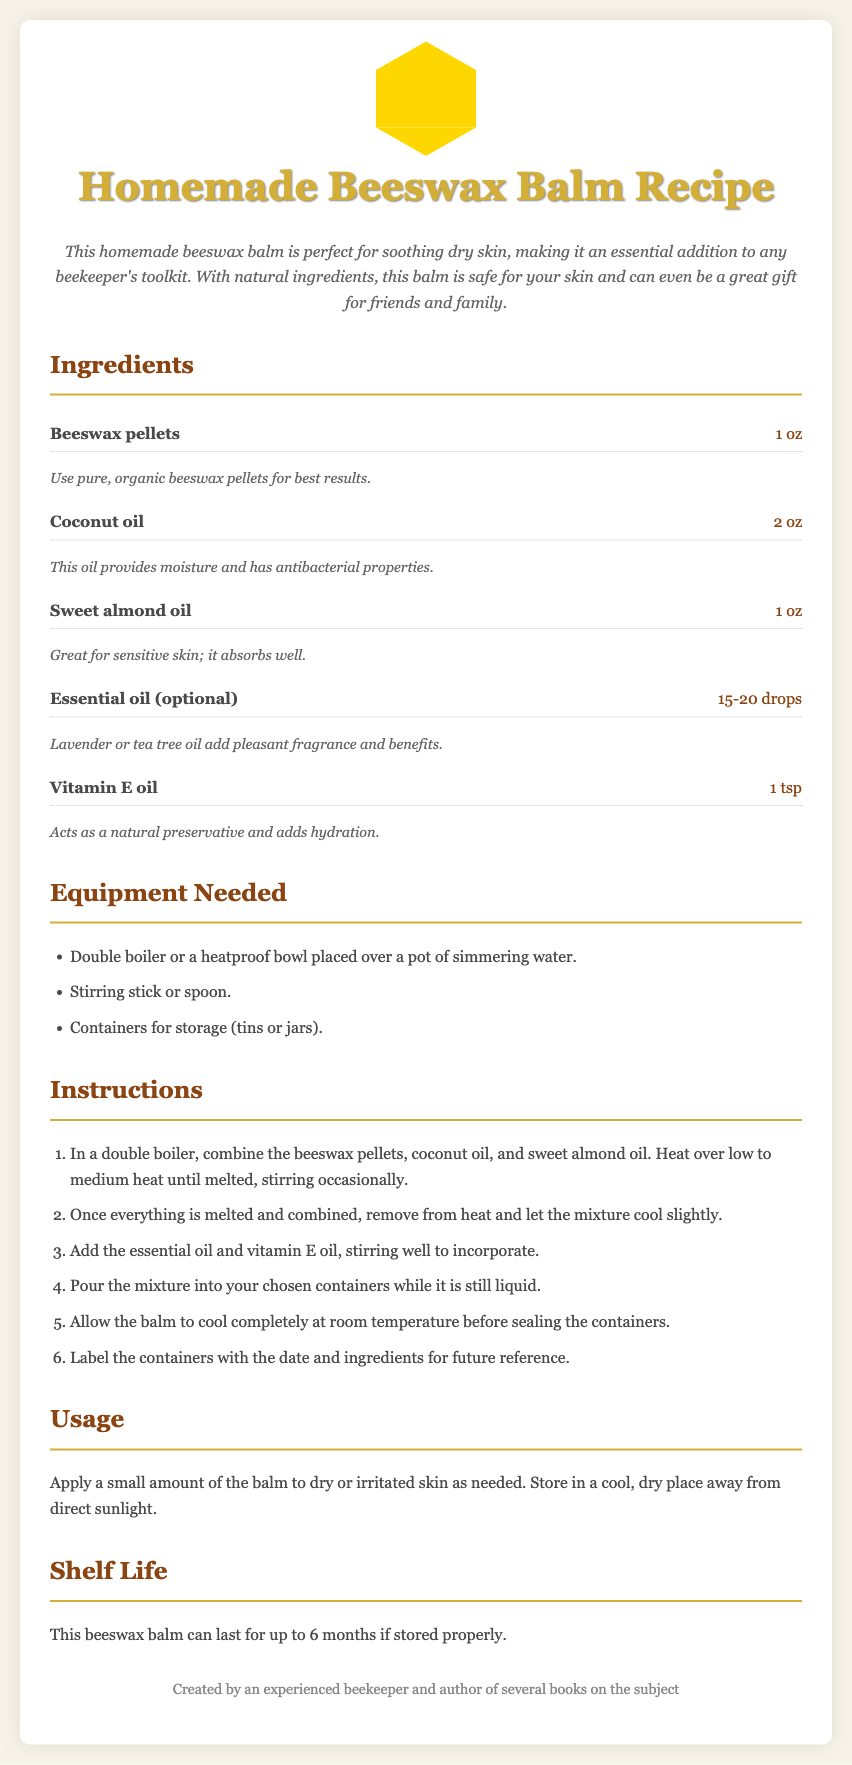What is the total amount of beeswax pellets needed? The total amount of beeswax pellets needed is specified as 1 oz in the ingredients section.
Answer: 1 oz How many drops of essential oil are suggested? The suggested amount of essential oil is between 15-20 drops, mentioned in the ingredients.
Answer: 15-20 drops What is the role of Vitamin E oil in the balm? The document states that Vitamin E oil acts as a natural preservative and adds hydration, found in the ingredient notes.
Answer: Natural preservative What equipment is required for making the balm? The required equipment is listed under "Equipment Needed," including a double boiler, stirring stick, and storage containers.
Answer: Double boiler How long can the beeswax balm last? The shelf life of the beeswax balm is mentioned to be up to 6 months if stored properly.
Answer: 6 months What should you apply the balm to? The usage section specifies that the balm should be applied to dry or irritated skin as needed.
Answer: Dry or irritated skin How many main ingredients are listed in the recipe? The ingredients section lists a total of five main ingredients needed for the recipe.
Answer: Five What should you do after pouring the mixture into containers? The instructions state that you should allow the balm to cool completely at room temperature before sealing the containers.
Answer: Cool completely What is the main purpose of this beeswax balm? The introduction highlights that this balm is perfect for soothing dry skin.
Answer: Soothing dry skin 